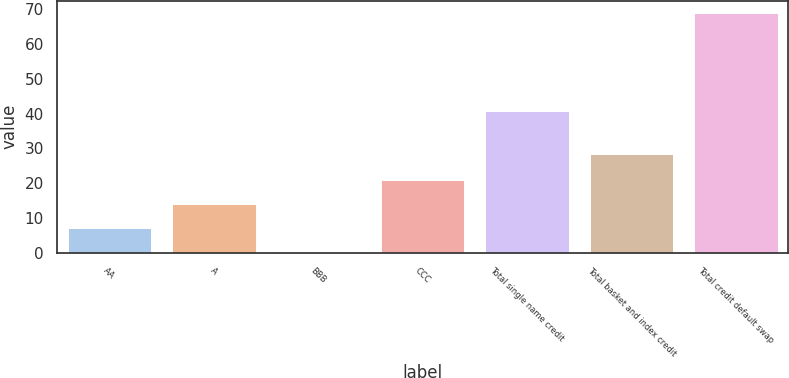<chart> <loc_0><loc_0><loc_500><loc_500><bar_chart><fcel>AA<fcel>A<fcel>BBB<fcel>CCC<fcel>Total single name credit<fcel>Total basket and index credit<fcel>Total credit default swap<nl><fcel>7.08<fcel>13.96<fcel>0.2<fcel>20.84<fcel>40.6<fcel>28.4<fcel>69<nl></chart> 